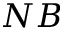Convert formula to latex. <formula><loc_0><loc_0><loc_500><loc_500>N B</formula> 